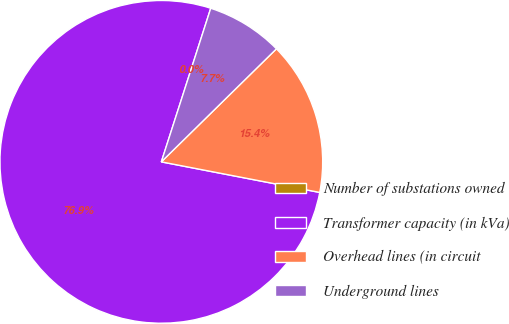Convert chart to OTSL. <chart><loc_0><loc_0><loc_500><loc_500><pie_chart><fcel>Number of substations owned<fcel>Transformer capacity (in kVa)<fcel>Overhead lines (in circuit<fcel>Underground lines<nl><fcel>0.0%<fcel>76.92%<fcel>15.39%<fcel>7.69%<nl></chart> 